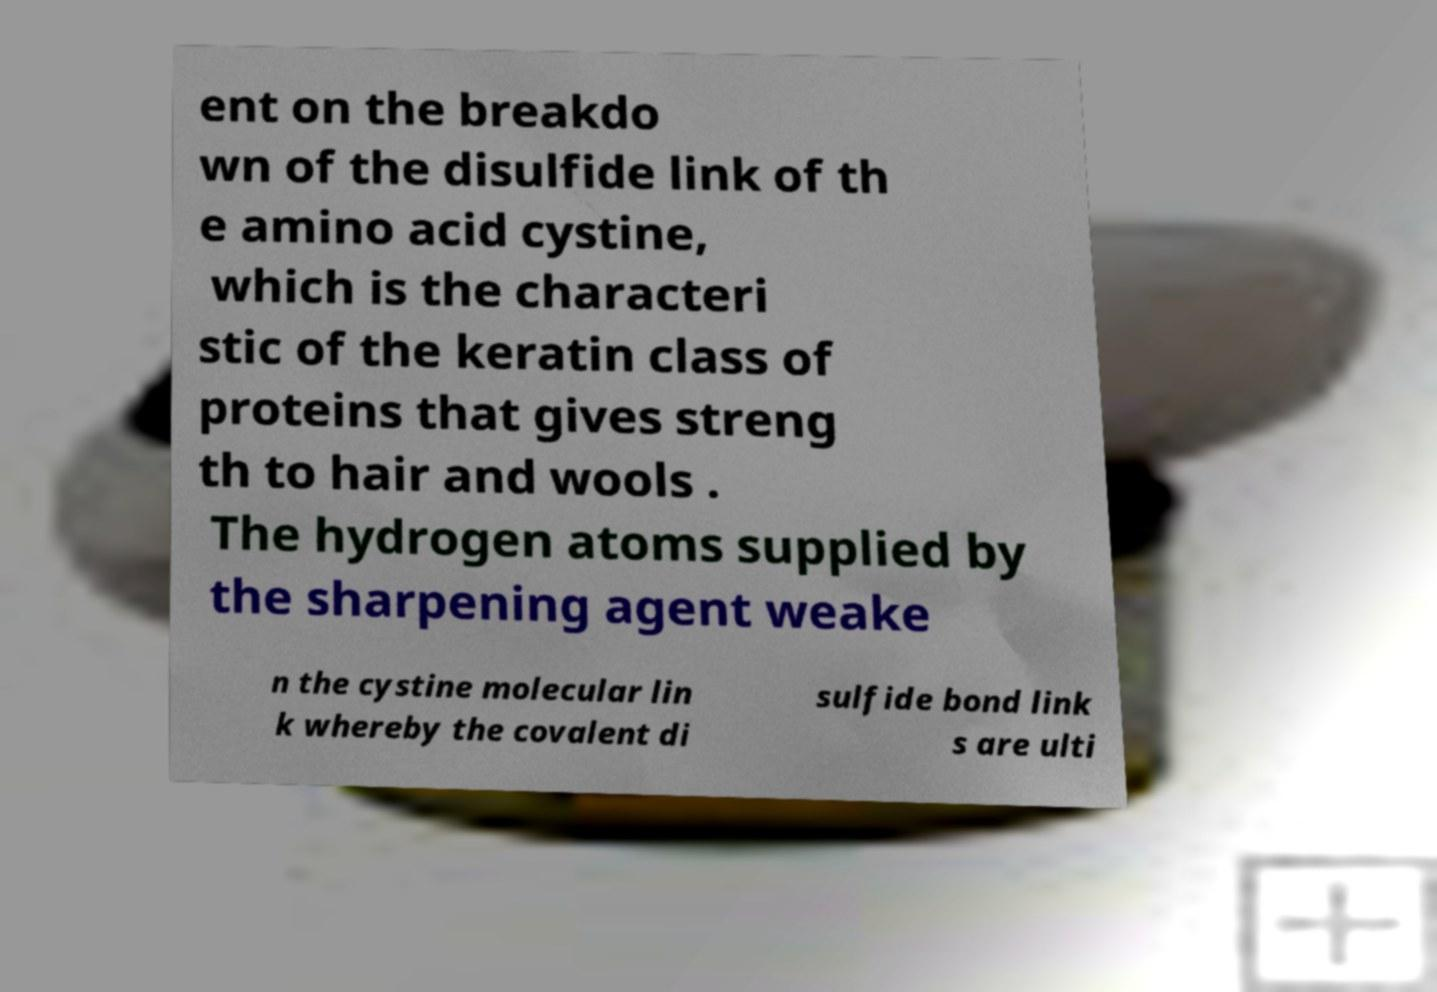I need the written content from this picture converted into text. Can you do that? ent on the breakdo wn of the disulfide link of th e amino acid cystine, which is the characteri stic of the keratin class of proteins that gives streng th to hair and wools . The hydrogen atoms supplied by the sharpening agent weake n the cystine molecular lin k whereby the covalent di sulfide bond link s are ulti 